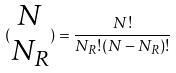<formula> <loc_0><loc_0><loc_500><loc_500>( \begin{matrix} N \\ N _ { R } \end{matrix} ) = \frac { N ! } { N _ { R } ! ( N - N _ { R } ) ! }</formula> 